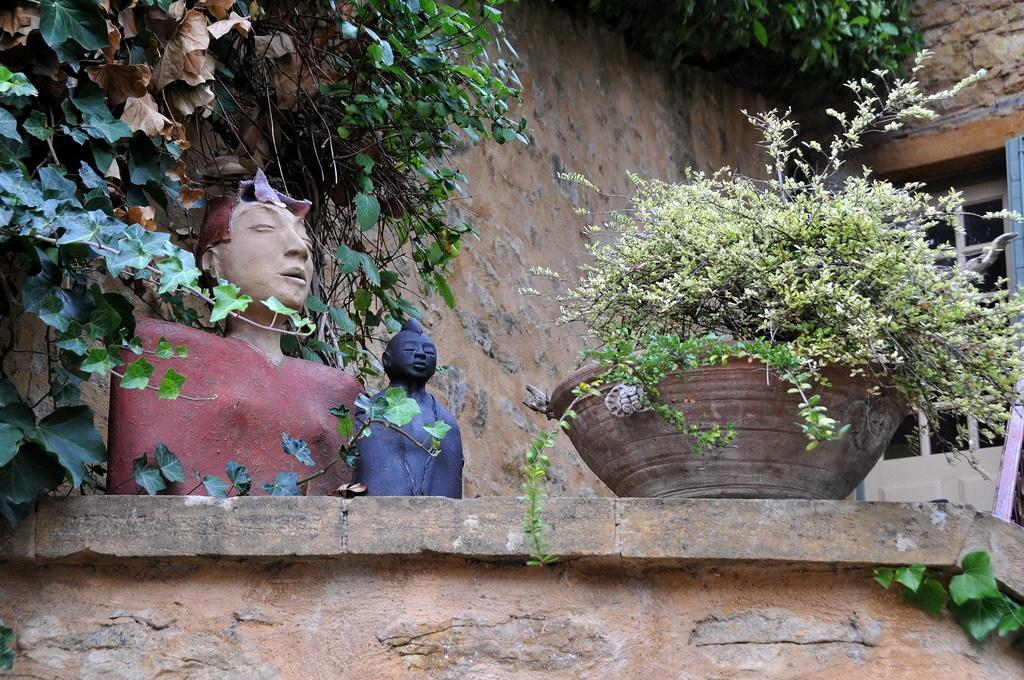What is on the wall in the foreground of the image? There are plants and two sculptures on the wall in the foreground of the image. What can be seen in the background of the image? There is a wall and a door in the background of the image, as well as plants on the top. How many sculptures are on the wall in the foreground? There are two sculptures on the wall in the foreground. Is the camera visible in the image? There is no camera present in the image. Does the existence of plants on the wall in the foreground imply the existence of plants in the background? The presence of plants on the wall in the foreground does not necessarily imply the existence of plants in the background, as the facts only mention plants on the top in the background. 